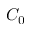Convert formula to latex. <formula><loc_0><loc_0><loc_500><loc_500>C _ { 0 }</formula> 